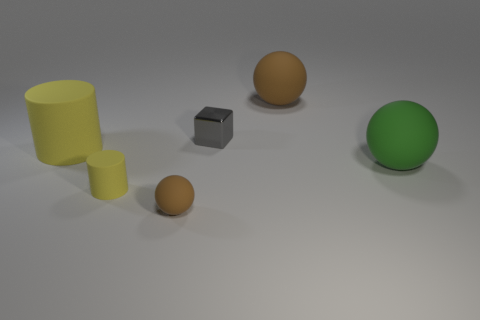Does the small shiny thing have the same shape as the brown thing behind the tiny shiny cube?
Your answer should be very brief. No. What is the color of the rubber object that is left of the gray shiny cube and behind the green object?
Give a very brief answer. Yellow. Is there a tiny yellow object of the same shape as the small brown object?
Give a very brief answer. No. Do the metal block and the tiny matte ball have the same color?
Make the answer very short. No. There is a yellow matte object in front of the green matte ball; are there any small yellow cylinders behind it?
Give a very brief answer. No. How many objects are matte spheres that are behind the big matte cylinder or matte spheres that are behind the gray shiny object?
Provide a succinct answer. 1. What number of objects are big brown spheres or things in front of the big green rubber thing?
Provide a short and direct response. 3. How big is the brown rubber ball behind the brown object that is in front of the big yellow matte object that is on the left side of the small yellow thing?
Offer a terse response. Large. What is the material of the yellow thing that is the same size as the green object?
Your response must be concise. Rubber. Is there a blue matte cylinder of the same size as the green matte object?
Your answer should be compact. No. 